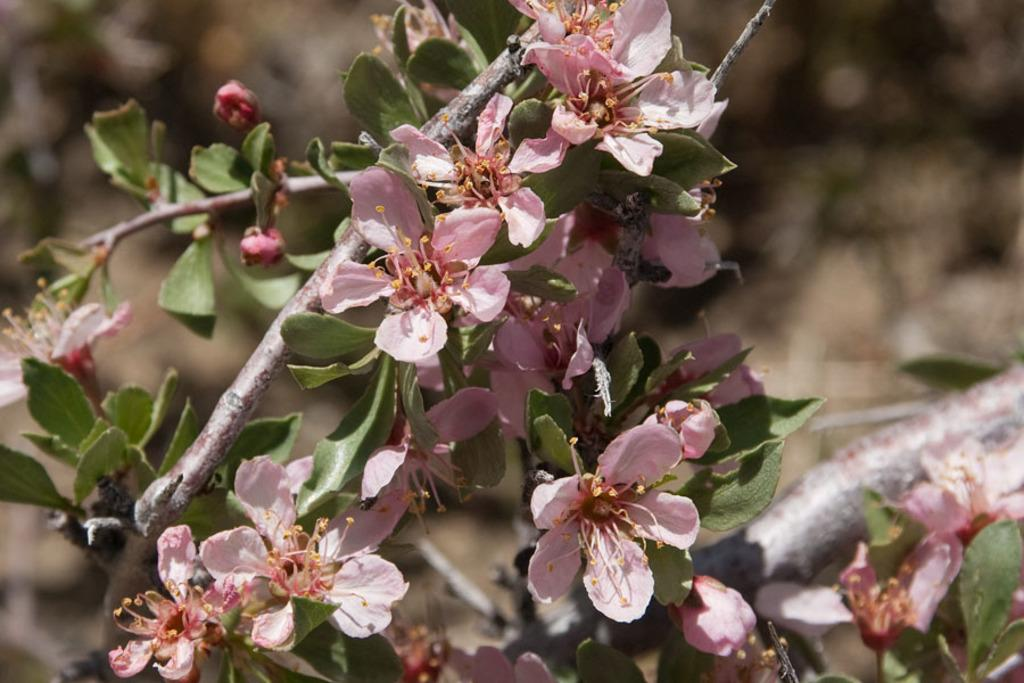What is present in the image? There is a plant in the image. What can be observed about the plant? The plant has flowers. What type of cast can be seen on the plant in the image? There is no cast present on the plant in the image. What role does the minister play in relation to the plant in the image? There is no minister present in the image, so there is no role for them to play. 